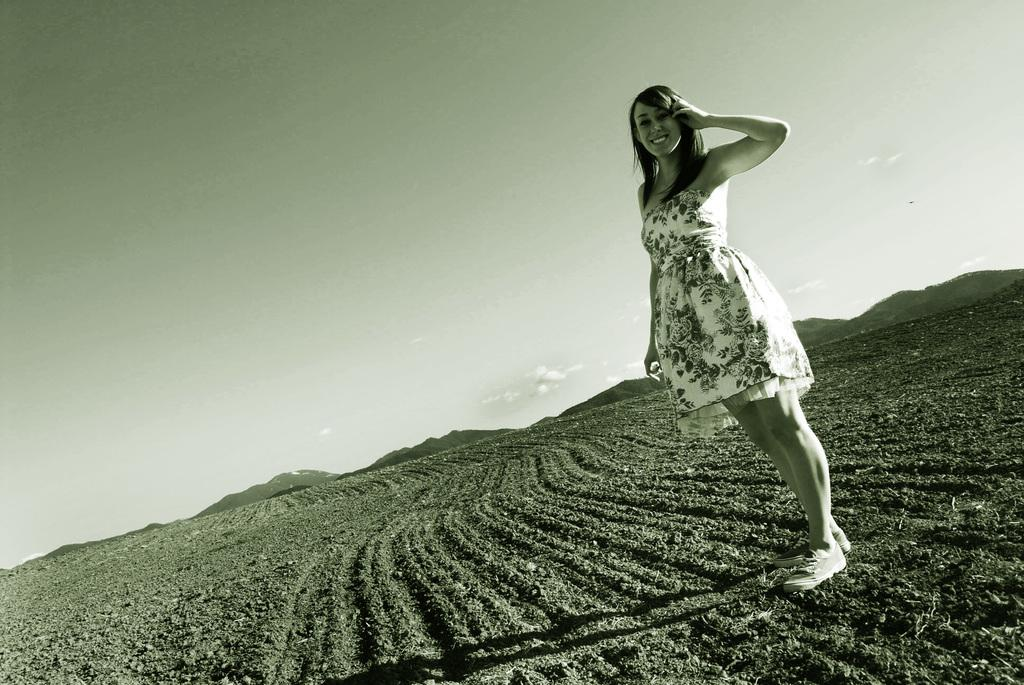Who is the main subject in the image? There is a woman in the image. What is the woman wearing? The woman is wearing a frock. What is the woman's facial expression? The woman is smiling. What type of surface is the woman standing on? The woman is standing on the soil. What can be seen in the background of the image? Hills and the sky are visible in the background of the image. What type of brick is the woman using to build a wall in the image? There is no brick or wall-building activity present in the image. 